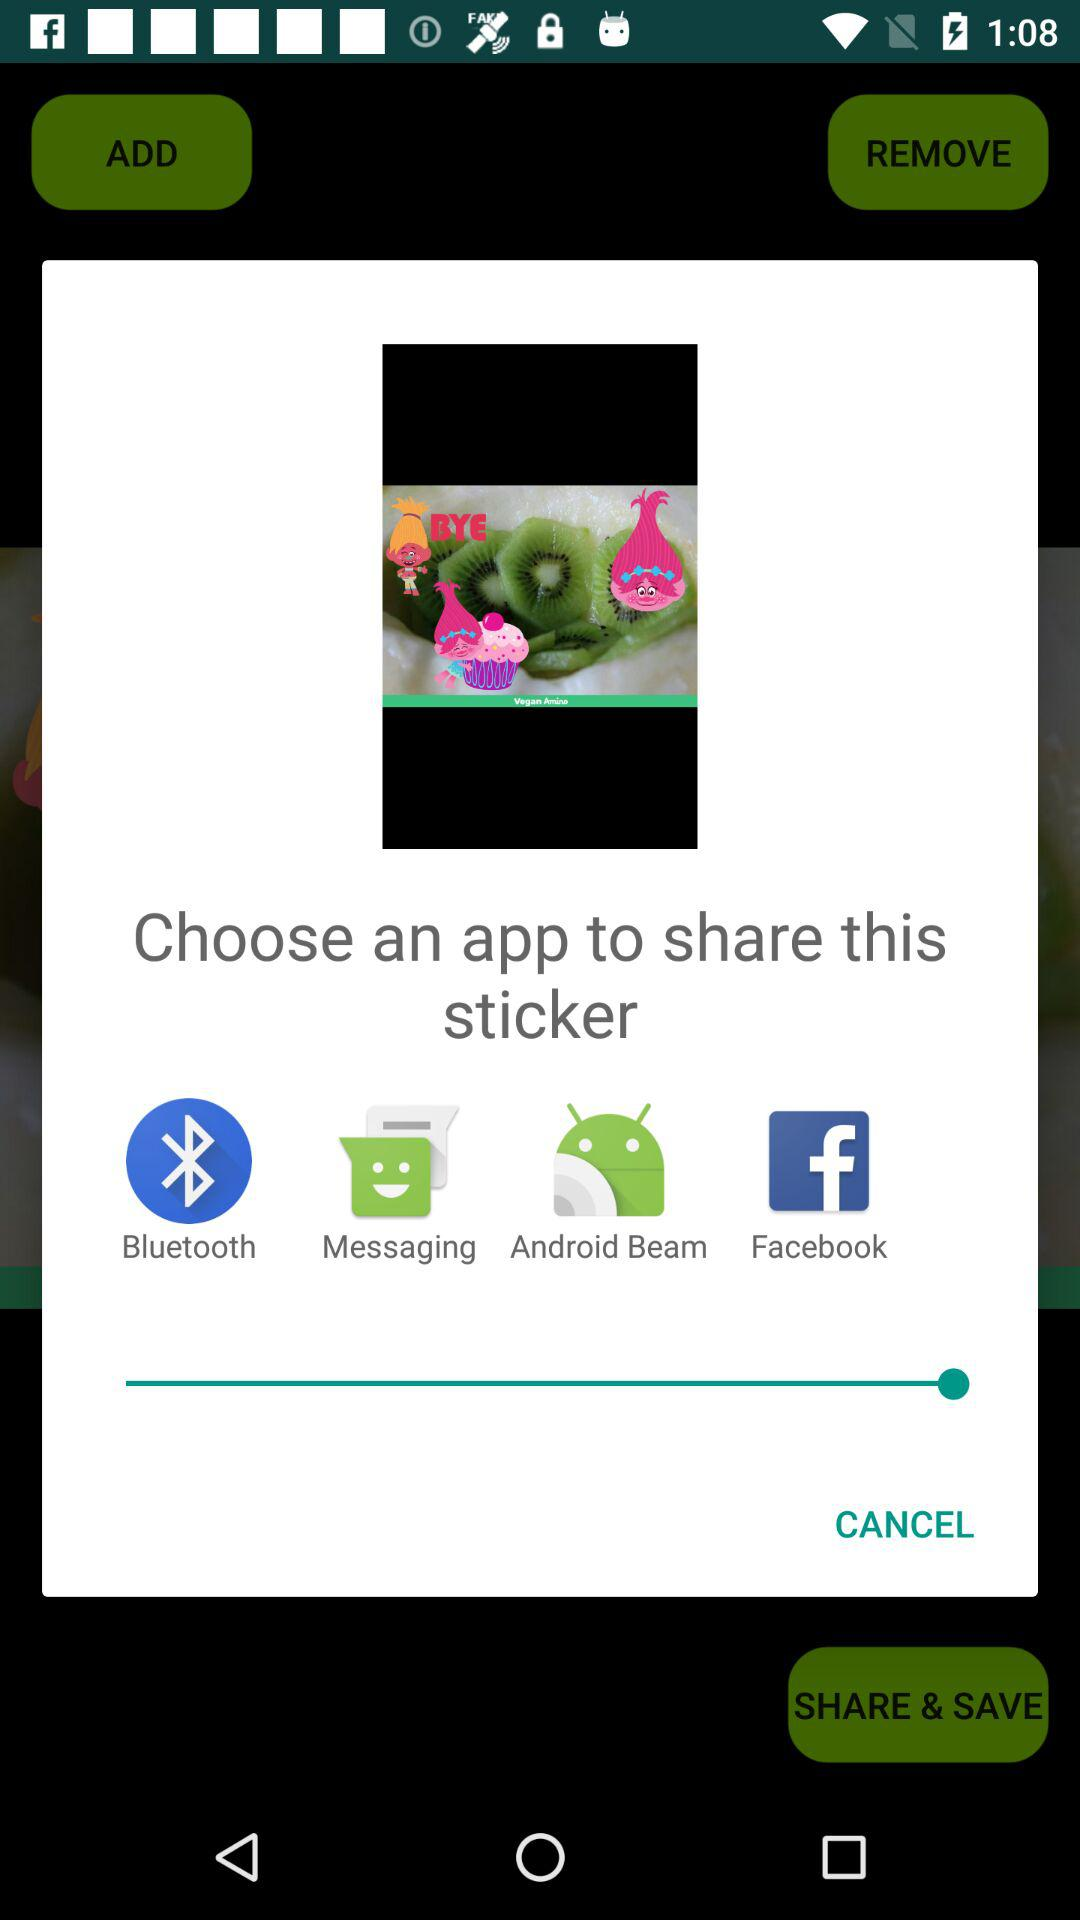How many apps can you share the sticker with?
Answer the question using a single word or phrase. 4 